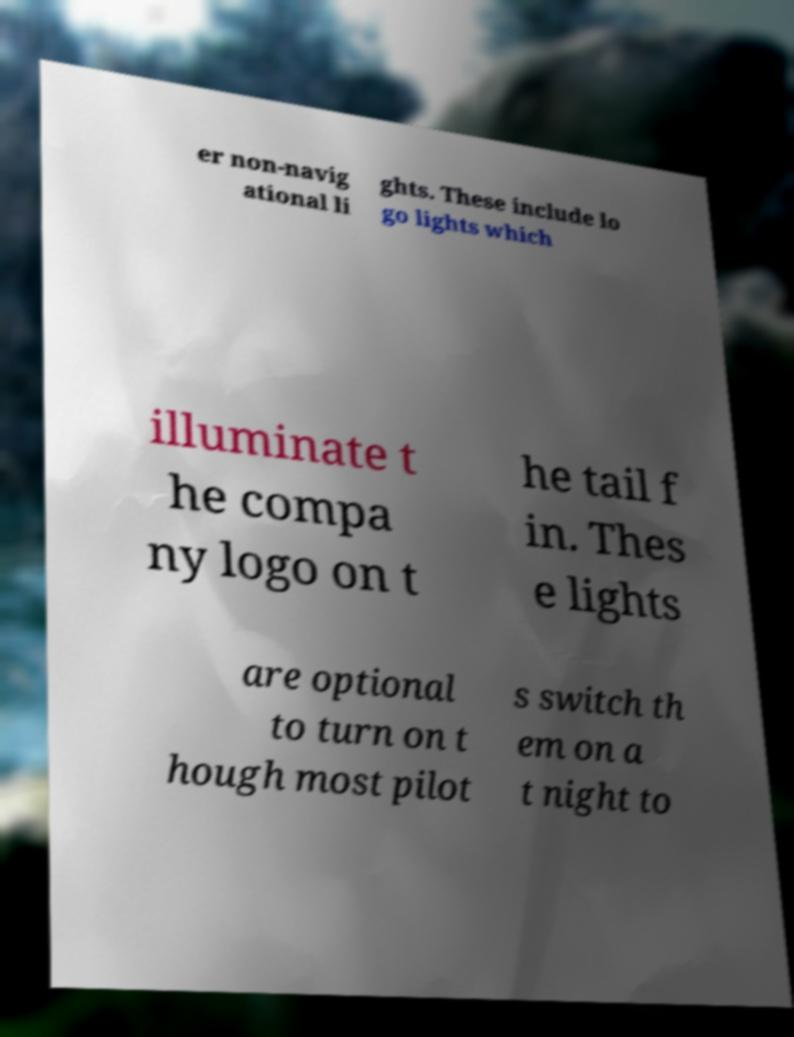Please identify and transcribe the text found in this image. er non-navig ational li ghts. These include lo go lights which illuminate t he compa ny logo on t he tail f in. Thes e lights are optional to turn on t hough most pilot s switch th em on a t night to 